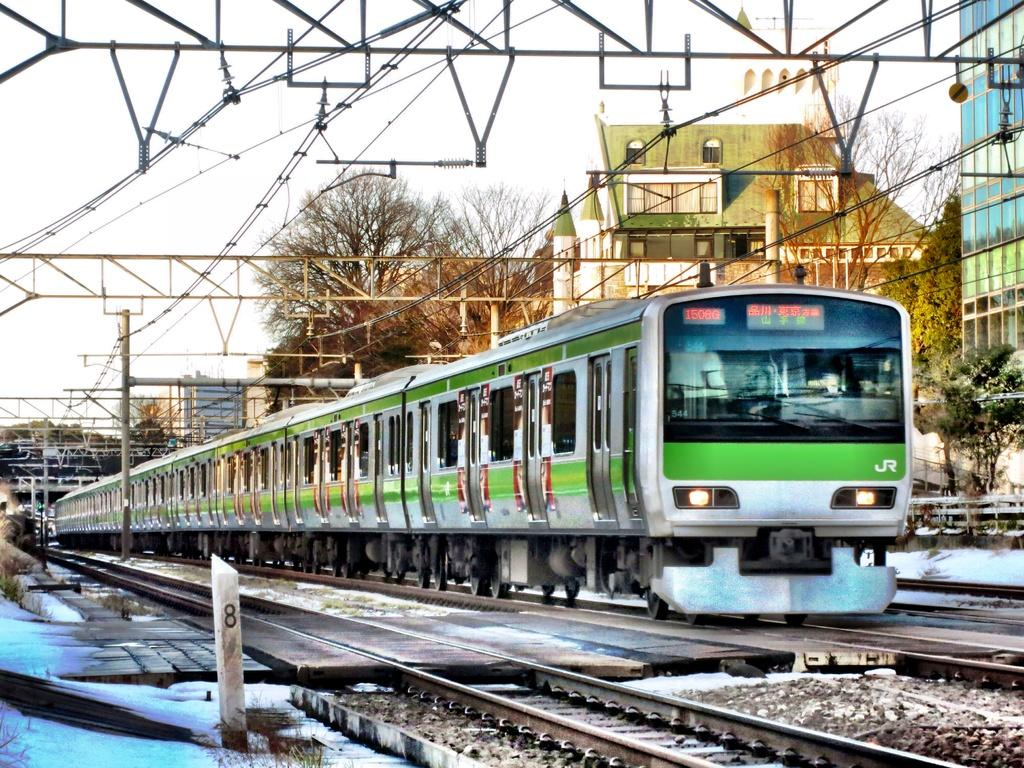What is the main subject of the image? The main subject of the image is a train. What can be seen in the background of the image? There are buildings, trees, and the sky visible in the image. What is the train positioned on? The train is positioned on a track. What infrastructure is present in the image? There are poles with metal construction, electric wires, and signaling devices present in the image. Can you see a basketball being played in the image? No, there is no basketball or any indication of a game being played in the image. Is there a ring visible in the image? No, there is no ring present in the image. 